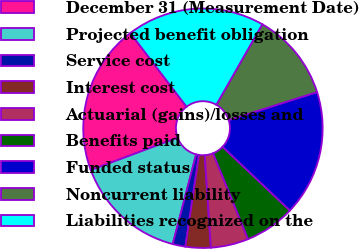<chart> <loc_0><loc_0><loc_500><loc_500><pie_chart><fcel>December 31 (Measurement Date)<fcel>Projected benefit obligation<fcel>Service cost<fcel>Interest cost<fcel>Actuarial (gains)/losses and<fcel>Benefits paid<fcel>Funded status<fcel>Noncurrent liability<fcel>Liabilities recognized on the<nl><fcel>20.32%<fcel>15.25%<fcel>1.71%<fcel>3.4%<fcel>5.09%<fcel>6.79%<fcel>16.94%<fcel>11.86%<fcel>18.63%<nl></chart> 